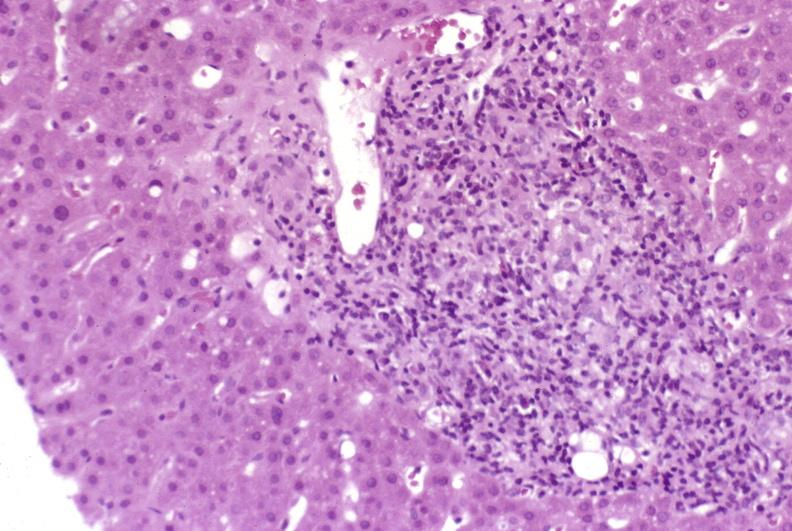does metastatic malignant melanoma show mild-to-moderate acute rejection?
Answer the question using a single word or phrase. No 